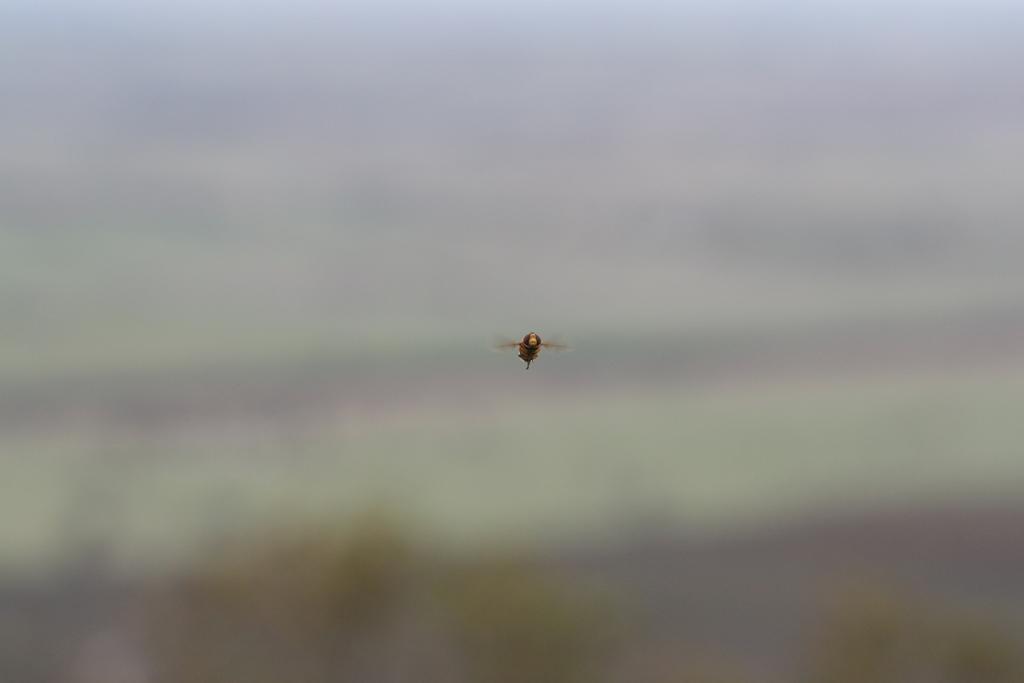Please provide a concise description of this image. In the middle of this image there is a bee flying in the air. The background is blurred. 